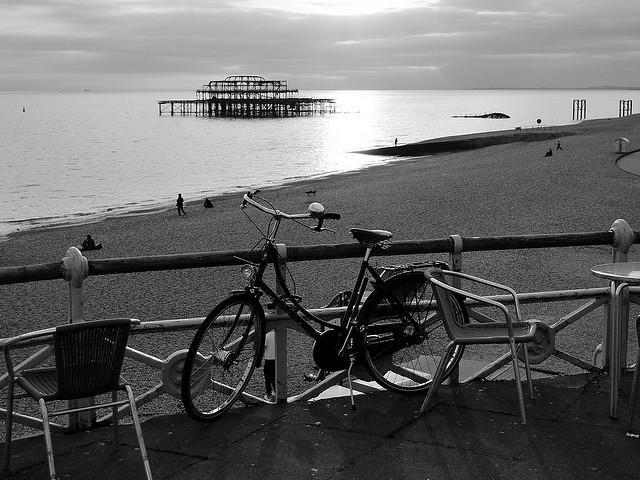What company make's the bike?
Quick response, please. Schwinn. What is on the front of the bike?
Keep it brief. Handlebars. What type of transportation is next to the rail?
Give a very brief answer. Bicycle. Is this a bike storage?
Short answer required. No. Is there a cruise ship?
Be succinct. No. How many chairs are on the deck?
Be succinct. 2. Is this picture of a desert landscape?
Keep it brief. No. Is this bike ready to ride?
Concise answer only. Yes. Is the bike chained up?
Answer briefly. Yes. 